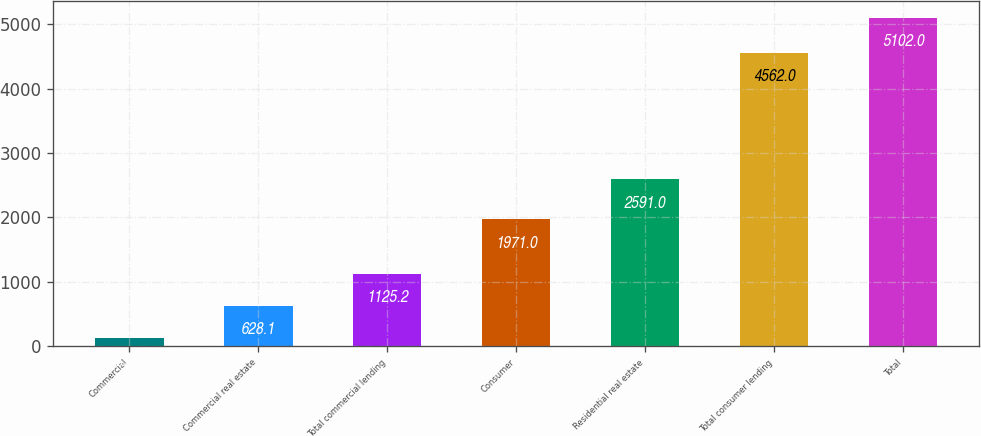Convert chart. <chart><loc_0><loc_0><loc_500><loc_500><bar_chart><fcel>Commercial<fcel>Commercial real estate<fcel>Total commercial lending<fcel>Consumer<fcel>Residential real estate<fcel>Total consumer lending<fcel>Total<nl><fcel>131<fcel>628.1<fcel>1125.2<fcel>1971<fcel>2591<fcel>4562<fcel>5102<nl></chart> 